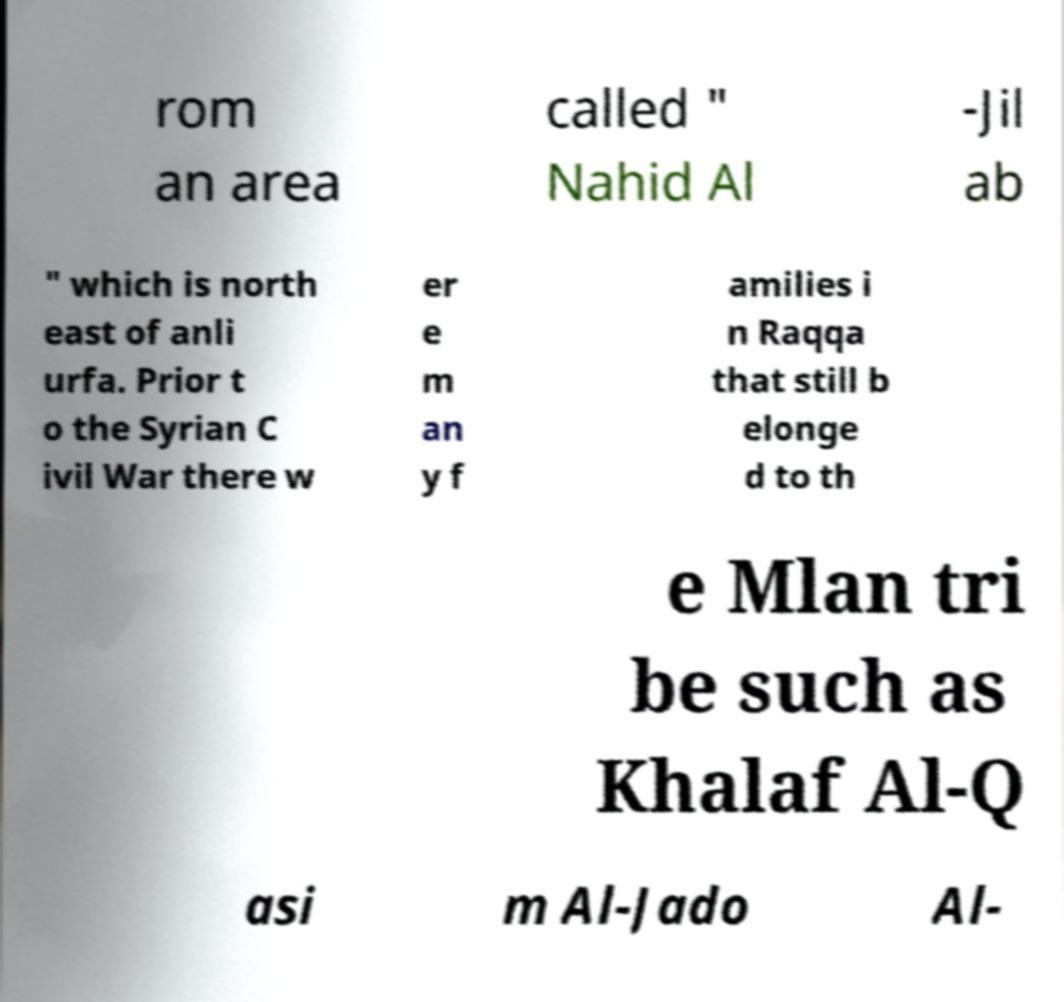Could you extract and type out the text from this image? rom an area called " Nahid Al -Jil ab " which is north east of anli urfa. Prior t o the Syrian C ivil War there w er e m an y f amilies i n Raqqa that still b elonge d to th e Mlan tri be such as Khalaf Al-Q asi m Al-Jado Al- 